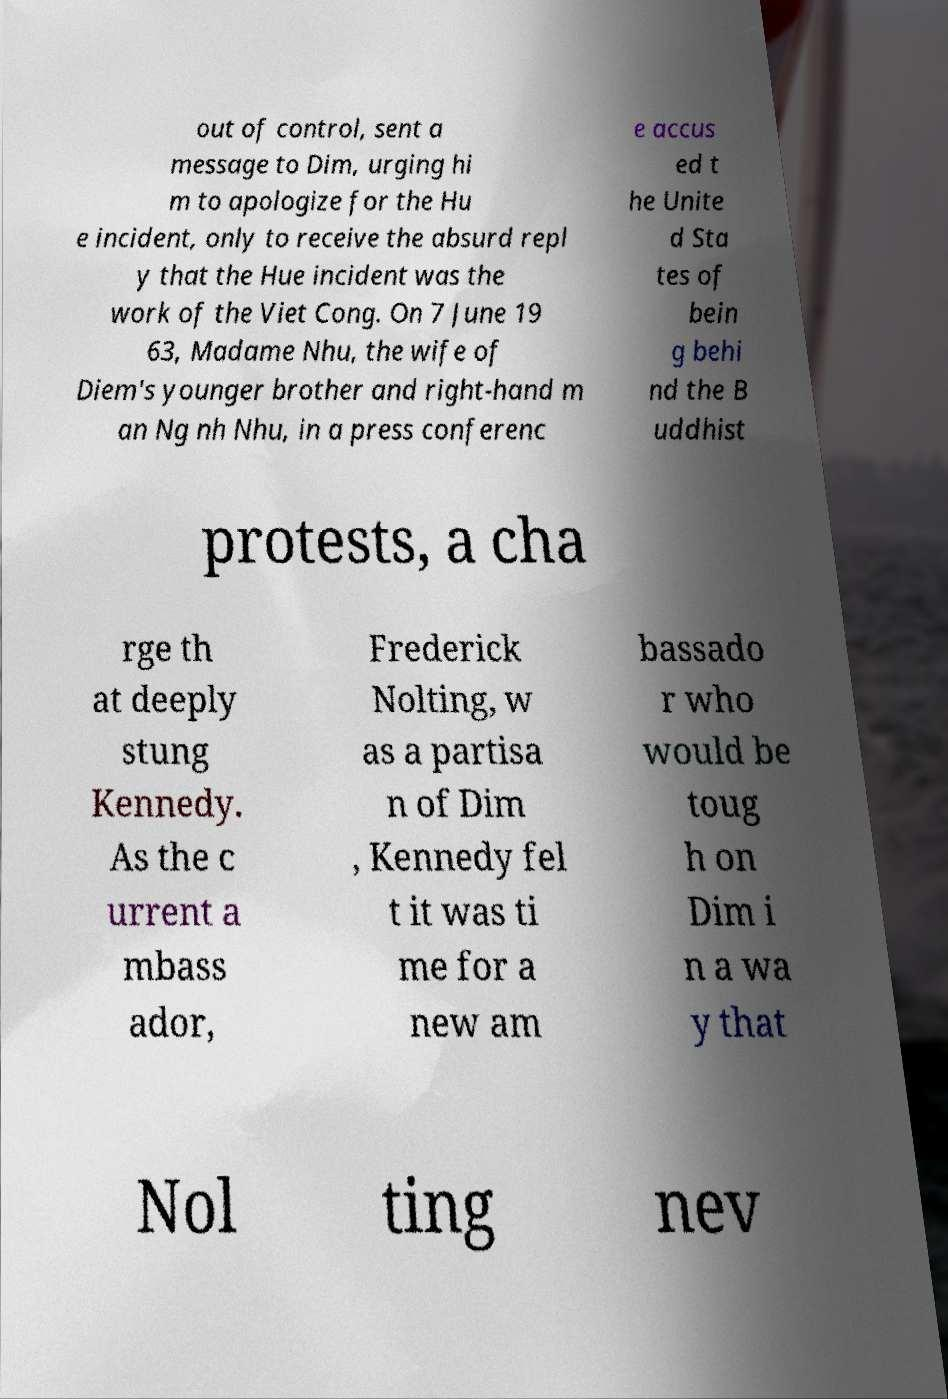Can you read and provide the text displayed in the image?This photo seems to have some interesting text. Can you extract and type it out for me? out of control, sent a message to Dim, urging hi m to apologize for the Hu e incident, only to receive the absurd repl y that the Hue incident was the work of the Viet Cong. On 7 June 19 63, Madame Nhu, the wife of Diem's younger brother and right-hand m an Ng nh Nhu, in a press conferenc e accus ed t he Unite d Sta tes of bein g behi nd the B uddhist protests, a cha rge th at deeply stung Kennedy. As the c urrent a mbass ador, Frederick Nolting, w as a partisa n of Dim , Kennedy fel t it was ti me for a new am bassado r who would be toug h on Dim i n a wa y that Nol ting nev 